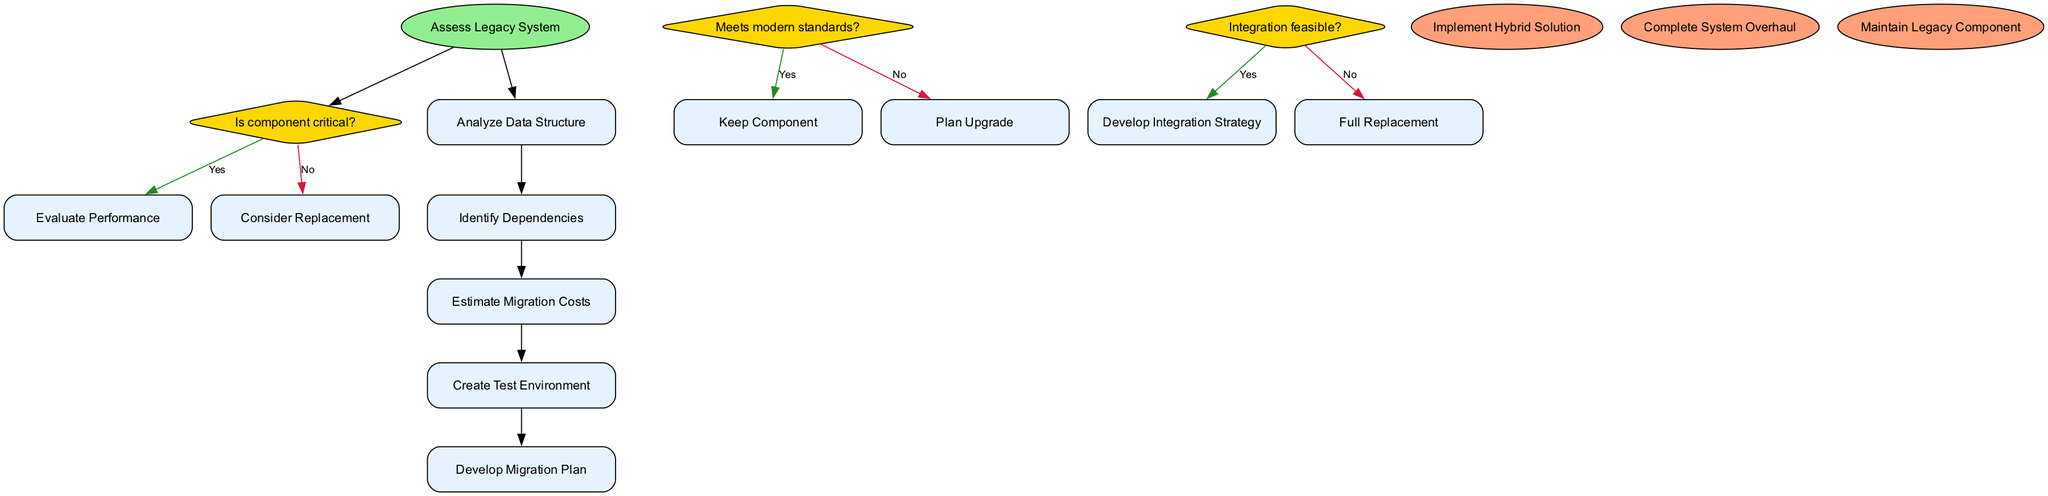What is the starting node of the flowchart? The starting node is labeled "Assess Legacy System" and it serves as the entry point for the entire flowchart.
Answer: Assess Legacy System How many decision points are in the diagram? There are three decision points, each represented as a diamond shape, asking questions about the components of the legacy system.
Answer: 3 What process follows the decision "Is component critical?" with a "Yes" answer? The process that follows this decision is "Evaluate Performance," indicating that if a component is critical, its performance must be evaluated next.
Answer: Evaluate Performance What happens if a component does not meet modern standards? If a component does not meet modern standards, the flowchart leads to the process "Plan Upgrade," suggesting an upgrade strategy is necessary.
Answer: Plan Upgrade Which end node results from a "No" answer at the decision "Integration feasible?" A "No" answer at the integration feasibility decision leads directly to the end node "Full Replacement," indicating that if integration is not feasible, a full system replacement is required.
Answer: Full Replacement What is the final process in the flowchart? The final process listed in the flowchart is "Develop Migration Plan," which indicates that after analyzing data and understanding dependencies, a migration plan must be developed.
Answer: Develop Migration Plan What is the color of the start node in the diagram? The start node is colored light green, represented with the hex value "#90EE90," indicating it is distinct from other nodes in the diagram.
Answer: Light green If a component is kept, what is the ultimate outcome in the diagram? Keeping a component leads to the end node "Maintain Legacy Component," indicating that if it remains relevant and effective, it will be maintained instead of replaced.
Answer: Maintain Legacy Component How many end nodes does the flowchart feature? The flowchart features three end nodes, representing different outcomes based on the decisions made throughout the migration process.
Answer: 3 